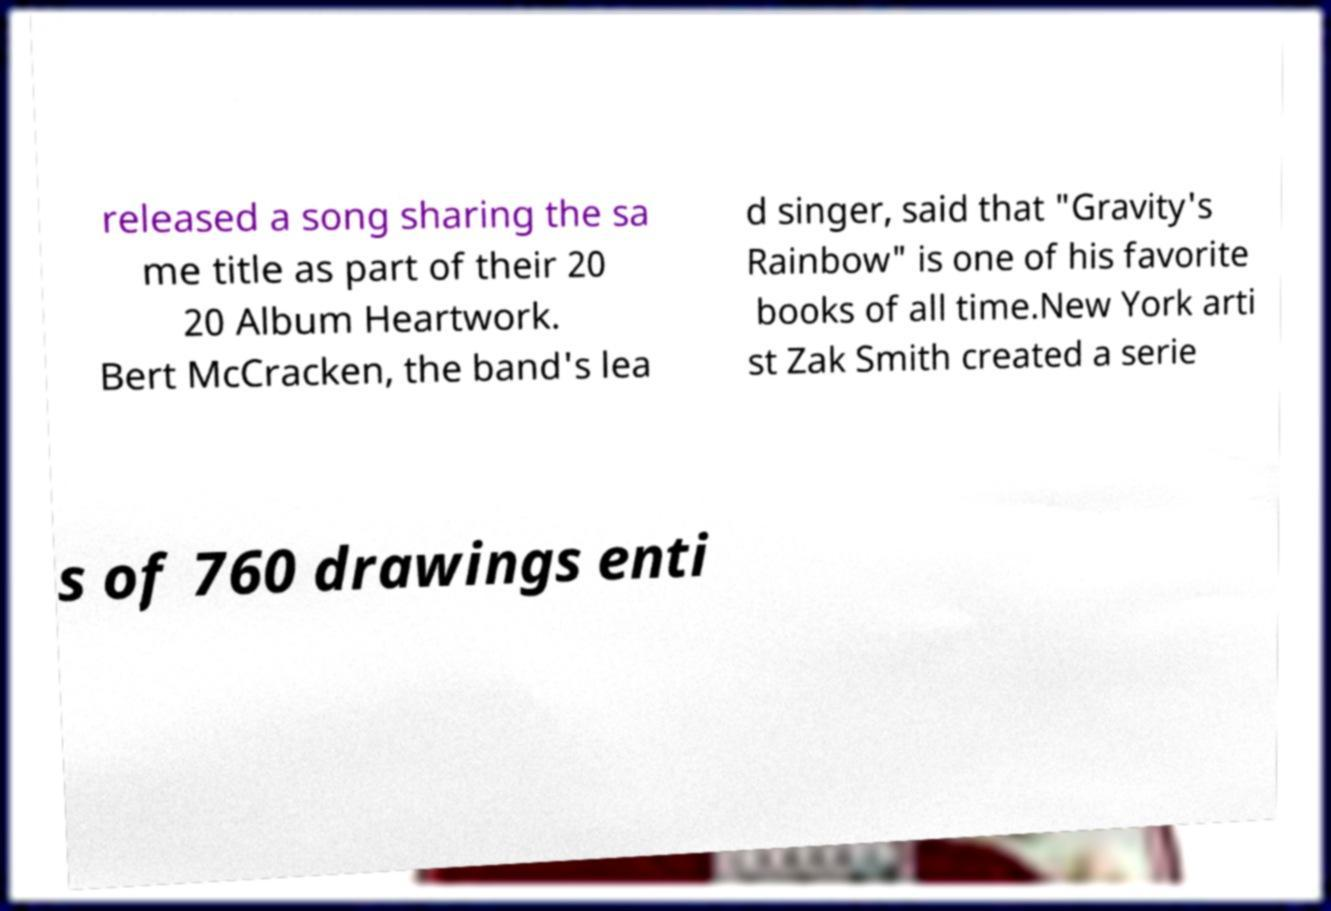Could you assist in decoding the text presented in this image and type it out clearly? released a song sharing the sa me title as part of their 20 20 Album Heartwork. Bert McCracken, the band's lea d singer, said that "Gravity's Rainbow" is one of his favorite books of all time.New York arti st Zak Smith created a serie s of 760 drawings enti 